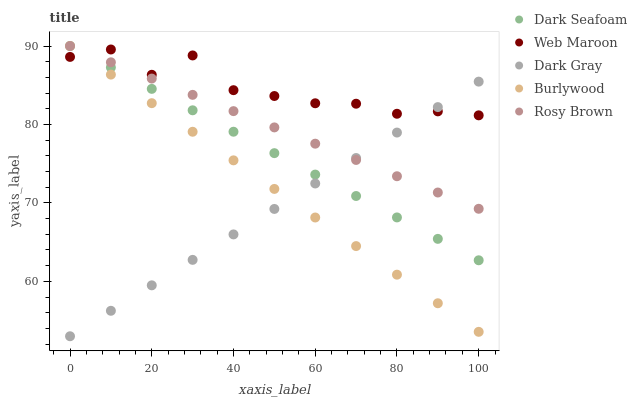Does Dark Gray have the minimum area under the curve?
Answer yes or no. Yes. Does Web Maroon have the maximum area under the curve?
Answer yes or no. Yes. Does Burlywood have the minimum area under the curve?
Answer yes or no. No. Does Burlywood have the maximum area under the curve?
Answer yes or no. No. Is Burlywood the smoothest?
Answer yes or no. Yes. Is Web Maroon the roughest?
Answer yes or no. Yes. Is Dark Seafoam the smoothest?
Answer yes or no. No. Is Dark Seafoam the roughest?
Answer yes or no. No. Does Dark Gray have the lowest value?
Answer yes or no. Yes. Does Burlywood have the lowest value?
Answer yes or no. No. Does Rosy Brown have the highest value?
Answer yes or no. Yes. Does Web Maroon have the highest value?
Answer yes or no. No. Does Web Maroon intersect Burlywood?
Answer yes or no. Yes. Is Web Maroon less than Burlywood?
Answer yes or no. No. Is Web Maroon greater than Burlywood?
Answer yes or no. No. 